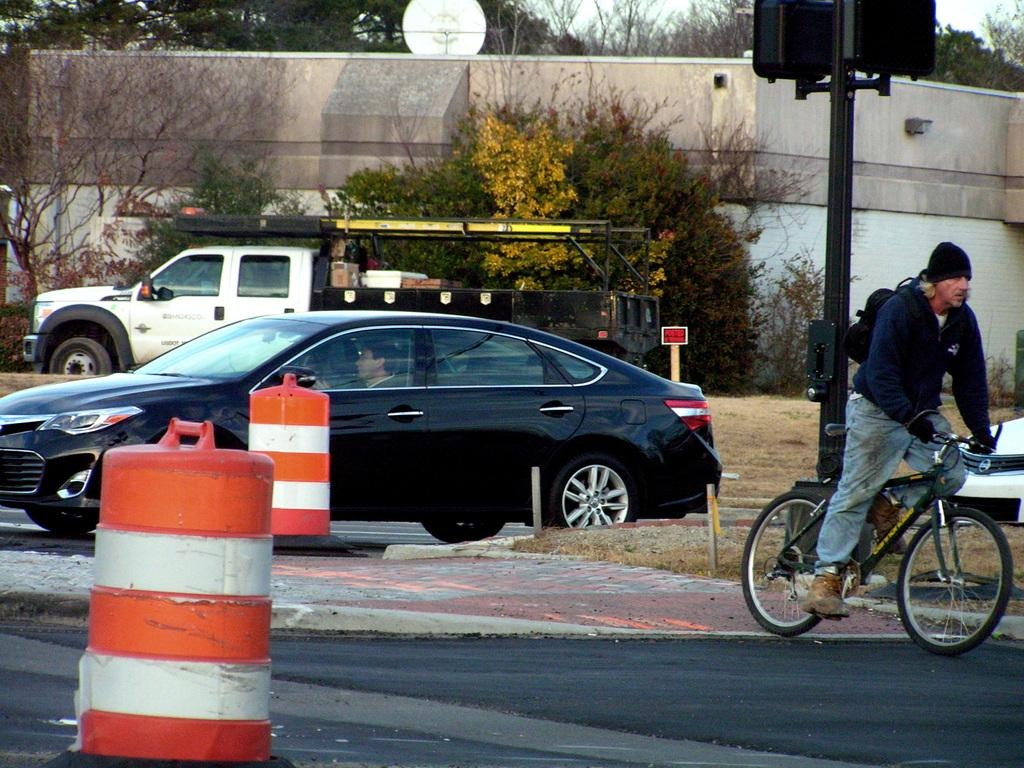What is the main subject of the image? There is a person riding a bicycle in the image. Where is the person riding the bicycle located in the image? The person is on the right side of the image. What can be seen in the background of the image? There are cars, a truck, trees, and a building in the background of the image. What type of board is the person riding in the image? The person is not riding a board in the image; they are riding a bicycle. Can you tell me how many brothers the person has in the image? There is no information about the person's family in the image, so it is not possible to determine the number of brothers they have. 